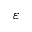Convert formula to latex. <formula><loc_0><loc_0><loc_500><loc_500>\varepsilon</formula> 